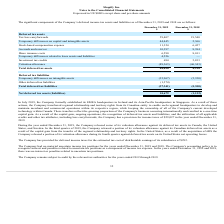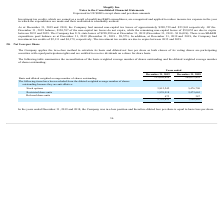From Shopify's financial document, What financial items does deferred tax assets comprise of? The document contains multiple relevant values: Tax loss carryforwards, Temporary differences on capital and intangible assets, Stock-based compensation expense, Accruals and reserves, Share issuance costs, Temporary differences related to lease assets and liabilities, Investment tax credits, Valuation allowance. From the document: "Tax loss carryforwards 59,407 19,540 Temporary differences related to lease assets and liabilities 4,526 — Accruals and reserves 10,397 8,384 Temporar..." Also, What financial items does deferred tax liabilities comprise of? The document shows two values: Temporary differences on intangible assets and Other deferred tax liabilities. From the document: "Temporary differences on intangible assets (35,967) (5,350) Other deferred tax liabilities (1,374) —..." Also, What is the total deferred tax liabilities as at December 31, 2019? According to the financial document, (37,341) (in thousands). The relevant text states: "Total deferred tax liabilities (37,341) (5,350)..." Also, can you calculate: What is the average total deferred tax assets for 2018 and 2019? To answer this question, I need to perform calculations using the financial data. The calculation is: (48,020+4,218)/2, which equals 26119 (in thousands). This is based on the information: "Total deferred tax assets 48,020 4,218 Total deferred tax assets 48,020 4,218..." The key data points involved are: 4,218, 48,020. Also, can you calculate: What is the average total deferred tax liabilities for 2018 and 2019? To answer this question, I need to perform calculations using the financial data. The calculation is: [(-37,341) + (-5,350)] /2, which equals -21345.5 (in thousands). This is based on the information: "Total deferred tax liabilities (37,341) (5,350) deferred income tax assets and liabilities as of December 31, 2019 and 2018 are as follows: Total deferred tax liabilities (37,341) (5,350)..." The key data points involved are: 37,341, 5,350. Additionally, Which year has the highest total deferred tax assets? According to the financial document, 2019. The relevant text states: "As at December 31, 2019 and 2018, the Company had unused non-capital tax losses of approximately $209,759 and $53,941 respe..." 